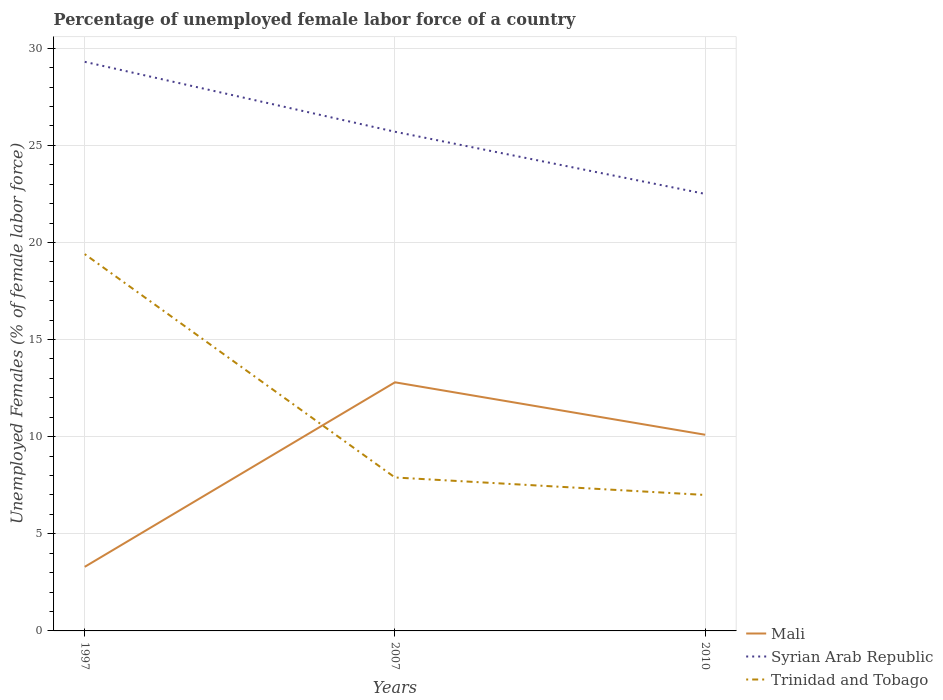Does the line corresponding to Trinidad and Tobago intersect with the line corresponding to Mali?
Your response must be concise. Yes. Across all years, what is the maximum percentage of unemployed female labor force in Mali?
Your answer should be compact. 3.3. In which year was the percentage of unemployed female labor force in Syrian Arab Republic maximum?
Ensure brevity in your answer.  2010. What is the total percentage of unemployed female labor force in Syrian Arab Republic in the graph?
Your answer should be compact. 3.6. What is the difference between the highest and the second highest percentage of unemployed female labor force in Syrian Arab Republic?
Make the answer very short. 6.8. How many lines are there?
Make the answer very short. 3. Does the graph contain any zero values?
Offer a very short reply. No. Where does the legend appear in the graph?
Make the answer very short. Bottom right. How are the legend labels stacked?
Provide a succinct answer. Vertical. What is the title of the graph?
Keep it short and to the point. Percentage of unemployed female labor force of a country. What is the label or title of the X-axis?
Keep it short and to the point. Years. What is the label or title of the Y-axis?
Provide a succinct answer. Unemployed Females (% of female labor force). What is the Unemployed Females (% of female labor force) in Mali in 1997?
Your answer should be compact. 3.3. What is the Unemployed Females (% of female labor force) in Syrian Arab Republic in 1997?
Offer a very short reply. 29.3. What is the Unemployed Females (% of female labor force) of Trinidad and Tobago in 1997?
Provide a short and direct response. 19.4. What is the Unemployed Females (% of female labor force) in Mali in 2007?
Keep it short and to the point. 12.8. What is the Unemployed Females (% of female labor force) of Syrian Arab Republic in 2007?
Provide a succinct answer. 25.7. What is the Unemployed Females (% of female labor force) in Trinidad and Tobago in 2007?
Your answer should be very brief. 7.9. What is the Unemployed Females (% of female labor force) of Mali in 2010?
Your response must be concise. 10.1. What is the Unemployed Females (% of female labor force) of Syrian Arab Republic in 2010?
Your answer should be compact. 22.5. What is the Unemployed Females (% of female labor force) in Trinidad and Tobago in 2010?
Offer a very short reply. 7. Across all years, what is the maximum Unemployed Females (% of female labor force) of Mali?
Your response must be concise. 12.8. Across all years, what is the maximum Unemployed Females (% of female labor force) in Syrian Arab Republic?
Ensure brevity in your answer.  29.3. Across all years, what is the maximum Unemployed Females (% of female labor force) in Trinidad and Tobago?
Keep it short and to the point. 19.4. Across all years, what is the minimum Unemployed Females (% of female labor force) of Mali?
Ensure brevity in your answer.  3.3. What is the total Unemployed Females (% of female labor force) of Mali in the graph?
Provide a short and direct response. 26.2. What is the total Unemployed Females (% of female labor force) of Syrian Arab Republic in the graph?
Keep it short and to the point. 77.5. What is the total Unemployed Females (% of female labor force) of Trinidad and Tobago in the graph?
Offer a very short reply. 34.3. What is the difference between the Unemployed Females (% of female labor force) in Syrian Arab Republic in 1997 and that in 2007?
Your answer should be compact. 3.6. What is the difference between the Unemployed Females (% of female labor force) in Mali in 1997 and that in 2010?
Offer a very short reply. -6.8. What is the difference between the Unemployed Females (% of female labor force) of Trinidad and Tobago in 1997 and that in 2010?
Provide a succinct answer. 12.4. What is the difference between the Unemployed Females (% of female labor force) of Mali in 2007 and that in 2010?
Ensure brevity in your answer.  2.7. What is the difference between the Unemployed Females (% of female labor force) in Mali in 1997 and the Unemployed Females (% of female labor force) in Syrian Arab Republic in 2007?
Provide a short and direct response. -22.4. What is the difference between the Unemployed Females (% of female labor force) in Syrian Arab Republic in 1997 and the Unemployed Females (% of female labor force) in Trinidad and Tobago in 2007?
Keep it short and to the point. 21.4. What is the difference between the Unemployed Females (% of female labor force) of Mali in 1997 and the Unemployed Females (% of female labor force) of Syrian Arab Republic in 2010?
Ensure brevity in your answer.  -19.2. What is the difference between the Unemployed Females (% of female labor force) in Mali in 1997 and the Unemployed Females (% of female labor force) in Trinidad and Tobago in 2010?
Ensure brevity in your answer.  -3.7. What is the difference between the Unemployed Females (% of female labor force) in Syrian Arab Republic in 1997 and the Unemployed Females (% of female labor force) in Trinidad and Tobago in 2010?
Give a very brief answer. 22.3. What is the difference between the Unemployed Females (% of female labor force) of Mali in 2007 and the Unemployed Females (% of female labor force) of Trinidad and Tobago in 2010?
Make the answer very short. 5.8. What is the average Unemployed Females (% of female labor force) of Mali per year?
Keep it short and to the point. 8.73. What is the average Unemployed Females (% of female labor force) in Syrian Arab Republic per year?
Your response must be concise. 25.83. What is the average Unemployed Females (% of female labor force) in Trinidad and Tobago per year?
Keep it short and to the point. 11.43. In the year 1997, what is the difference between the Unemployed Females (% of female labor force) of Mali and Unemployed Females (% of female labor force) of Syrian Arab Republic?
Give a very brief answer. -26. In the year 1997, what is the difference between the Unemployed Females (% of female labor force) of Mali and Unemployed Females (% of female labor force) of Trinidad and Tobago?
Make the answer very short. -16.1. In the year 2007, what is the difference between the Unemployed Females (% of female labor force) of Syrian Arab Republic and Unemployed Females (% of female labor force) of Trinidad and Tobago?
Keep it short and to the point. 17.8. In the year 2010, what is the difference between the Unemployed Females (% of female labor force) in Syrian Arab Republic and Unemployed Females (% of female labor force) in Trinidad and Tobago?
Offer a terse response. 15.5. What is the ratio of the Unemployed Females (% of female labor force) in Mali in 1997 to that in 2007?
Offer a very short reply. 0.26. What is the ratio of the Unemployed Females (% of female labor force) in Syrian Arab Republic in 1997 to that in 2007?
Make the answer very short. 1.14. What is the ratio of the Unemployed Females (% of female labor force) of Trinidad and Tobago in 1997 to that in 2007?
Ensure brevity in your answer.  2.46. What is the ratio of the Unemployed Females (% of female labor force) of Mali in 1997 to that in 2010?
Provide a succinct answer. 0.33. What is the ratio of the Unemployed Females (% of female labor force) in Syrian Arab Republic in 1997 to that in 2010?
Give a very brief answer. 1.3. What is the ratio of the Unemployed Females (% of female labor force) of Trinidad and Tobago in 1997 to that in 2010?
Offer a terse response. 2.77. What is the ratio of the Unemployed Females (% of female labor force) in Mali in 2007 to that in 2010?
Your answer should be compact. 1.27. What is the ratio of the Unemployed Females (% of female labor force) of Syrian Arab Republic in 2007 to that in 2010?
Offer a very short reply. 1.14. What is the ratio of the Unemployed Females (% of female labor force) of Trinidad and Tobago in 2007 to that in 2010?
Your answer should be compact. 1.13. What is the difference between the highest and the lowest Unemployed Females (% of female labor force) in Trinidad and Tobago?
Provide a succinct answer. 12.4. 